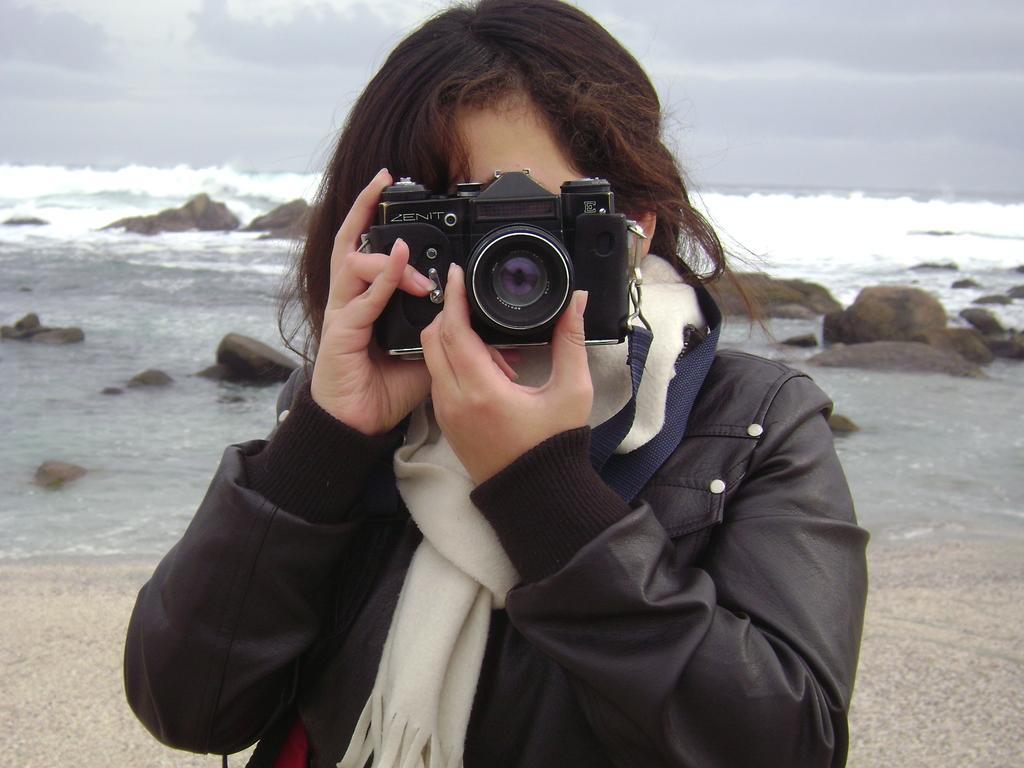Could you give a brief overview of what you see in this image? A woman is capturing a pic behind there are stones,water and sky. 